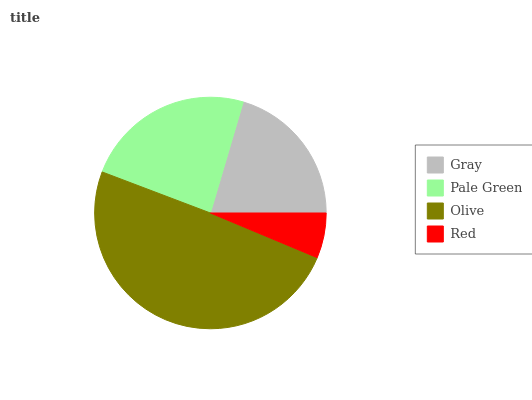Is Red the minimum?
Answer yes or no. Yes. Is Olive the maximum?
Answer yes or no. Yes. Is Pale Green the minimum?
Answer yes or no. No. Is Pale Green the maximum?
Answer yes or no. No. Is Pale Green greater than Gray?
Answer yes or no. Yes. Is Gray less than Pale Green?
Answer yes or no. Yes. Is Gray greater than Pale Green?
Answer yes or no. No. Is Pale Green less than Gray?
Answer yes or no. No. Is Pale Green the high median?
Answer yes or no. Yes. Is Gray the low median?
Answer yes or no. Yes. Is Gray the high median?
Answer yes or no. No. Is Pale Green the low median?
Answer yes or no. No. 